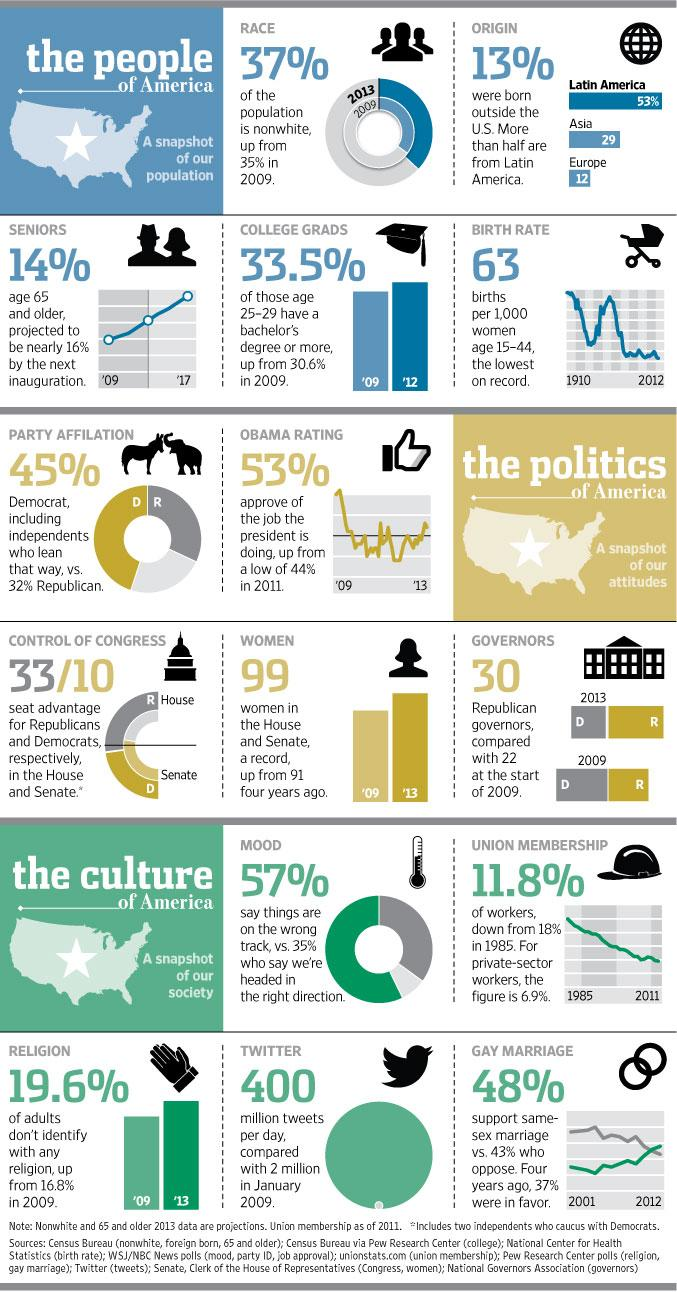Draw attention to some important aspects in this diagram. The current birth rate is 63 per thousand. In 2013, the number of adults who do not identify with any religion was higher than in 2009. Thirty governors, all of them Republicans. In 2009, there were 91 women serving in both the House and Senate. According to the given data, 33.5% of people in their late 20s hold a bachelor's degree or higher. 